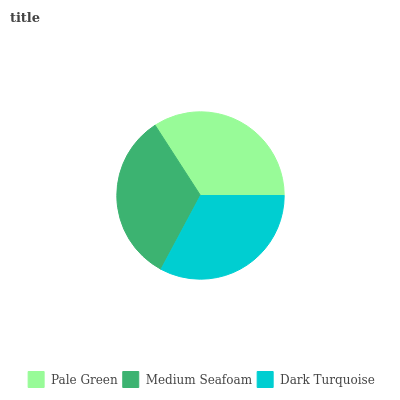Is Dark Turquoise the minimum?
Answer yes or no. Yes. Is Pale Green the maximum?
Answer yes or no. Yes. Is Medium Seafoam the minimum?
Answer yes or no. No. Is Medium Seafoam the maximum?
Answer yes or no. No. Is Pale Green greater than Medium Seafoam?
Answer yes or no. Yes. Is Medium Seafoam less than Pale Green?
Answer yes or no. Yes. Is Medium Seafoam greater than Pale Green?
Answer yes or no. No. Is Pale Green less than Medium Seafoam?
Answer yes or no. No. Is Medium Seafoam the high median?
Answer yes or no. Yes. Is Medium Seafoam the low median?
Answer yes or no. Yes. Is Dark Turquoise the high median?
Answer yes or no. No. Is Dark Turquoise the low median?
Answer yes or no. No. 